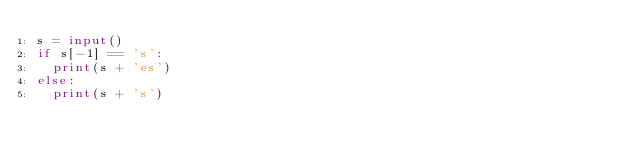<code> <loc_0><loc_0><loc_500><loc_500><_Python_>s = input()
if s[-1] == 's':
  print(s + 'es')
else:
  print(s + 's')</code> 